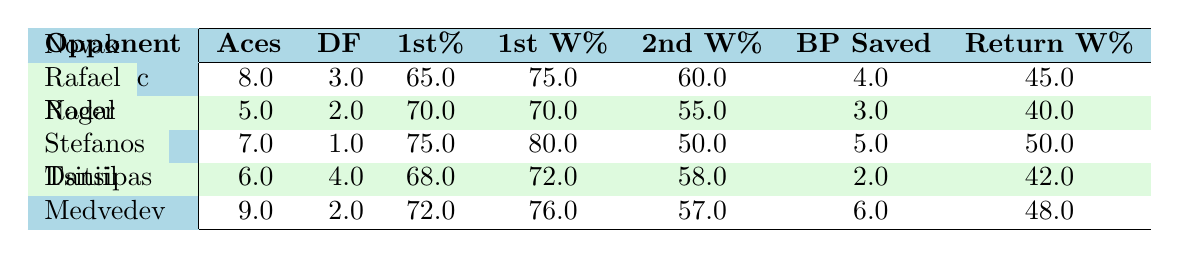What is the highest number of aces recorded among the matches? The highest number of aces can be found by comparing the "Aces" column for each opponent. Looking through the data, Daniil Medvedev has 9 aces, which is higher than the other players (8, 5, 7, and 6).
Answer: 9 Which match had the lowest first serve percentage? To find this, we look at the "1st%" column for each match and identify the minimum value. The lowest percentage is 65%, from the match against Novak Djokovic.
Answer: 65 How many total break points were saved across all matches? We sum the "BP Saved" column for all the matches: 4 + 3 + 5 + 2 + 6 = 20. This gives the total number of break points saved in the season.
Answer: 20 Did Rafael Nadal have more return points won than Roger Federer? By comparing the "Return W%" for both players, Rafael Nadal had 40 return points won while Roger Federer had 50. Since 40 is less than 50, the answer is no.
Answer: No What is the average first serve points won percentage across the season? We add the values in the "1st W%" column: 75 + 70 + 80 + 72 + 76 = 373. Then, we divide by the number of matches (5): 373 / 5 = 74.6%. This gives us the average first serve points won.
Answer: 74.6 Which opponent had the highest number of double faults? Looking at the "DF" column, we compare each opponent's counts. Stefanos Tsitsipas has the highest number of double faults with 4.
Answer: 4 Is it true that all matches had a first serve points won percentage above 70%? We check each value in the "1st W%" column. The values are 75, 70, 80, 72, and 76. Since Rafael Nadal had a percentage of exactly 70, not all values exceed 70. Thus, the statement is false.
Answer: No Which match had the highest return points won percentage? To determine this, we check the "Return W%" column for each match and find the highest value, which is 50% from the match against Roger Federer.
Answer: 50 